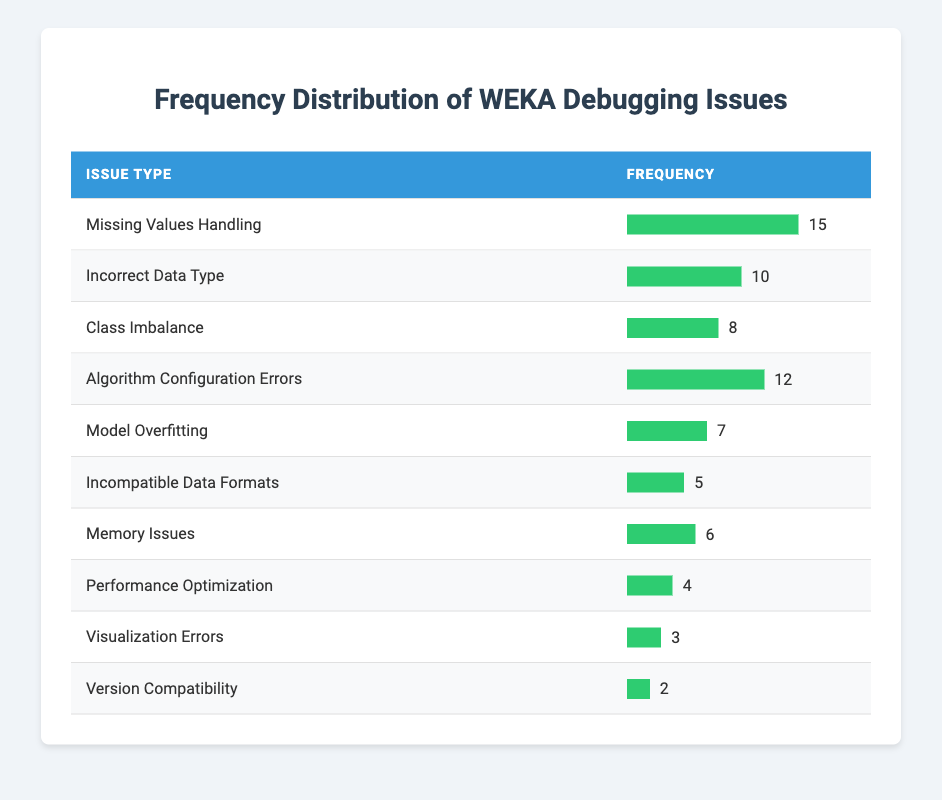What is the most frequent debugging issue encountered in WEKA? The table shows that "Missing Values Handling" has the highest frequency of 15, making it the most frequent debugging issue.
Answer: Missing Values Handling How many debugging issues have a frequency of 10 or more? From the table, the issues with a frequency of 10 or more are "Missing Values Handling" (15), "Incorrect Data Type" (10), and "Algorithm Configuration Errors" (12). That totals 3 issues.
Answer: 3 What is the total number of debugging issues listed in the table? By counting the rows in the table, there are 10 different debugging issues listed, each corresponding to one type of issue.
Answer: 10 Is "Memory Issues" the least frequent debugging issue in WEKA? The table shows that "Version Compatibility" has the lowest frequency at 2, which is less than "Memory Issues," which has 6. Thus, "Memory Issues" is not the least frequent issue.
Answer: No What is the difference in frequency between "Class Imbalance" and "Model Overfitting"? "Class Imbalance" has a frequency of 8 and "Model Overfitting" has a frequency of 7. Therefore, the difference is 8 - 7 = 1.
Answer: 1 What is the average frequency of the debugging issues listed? The frequencies are: 15, 10, 8, 12, 7, 5, 6, 4, 3, 2. Summing these gives 72, and dividing by 10 (the number of issues) results in an average of 7.2.
Answer: 7.2 Which debugging issue has a frequency closer to "Performance Optimization," and what is that frequency? "Performance Optimization" has a frequency of 4. "Memory Issues" (6) is closer to it with a difference of 2, while "Visualization Errors" (3) has a difference of 1. So, "Visualization Errors" is closer with a frequency of 3.
Answer: Visualization Errors How many more occurrences of "Incorrect Data Type" are there than "Incompatible Data Formats"? "Incorrect Data Type" has a frequency of 10 and "Incompatible Data Formats" has a frequency of 5. The difference is 10 - 5 = 5.
Answer: 5 Is the frequency of "Visualization Errors" higher than that of "Performance Optimization"? "Visualization Errors" has a frequency of 3 and "Performance Optimization" has a frequency of 4. Since 3 is not greater than 4, the statement is false.
Answer: No 